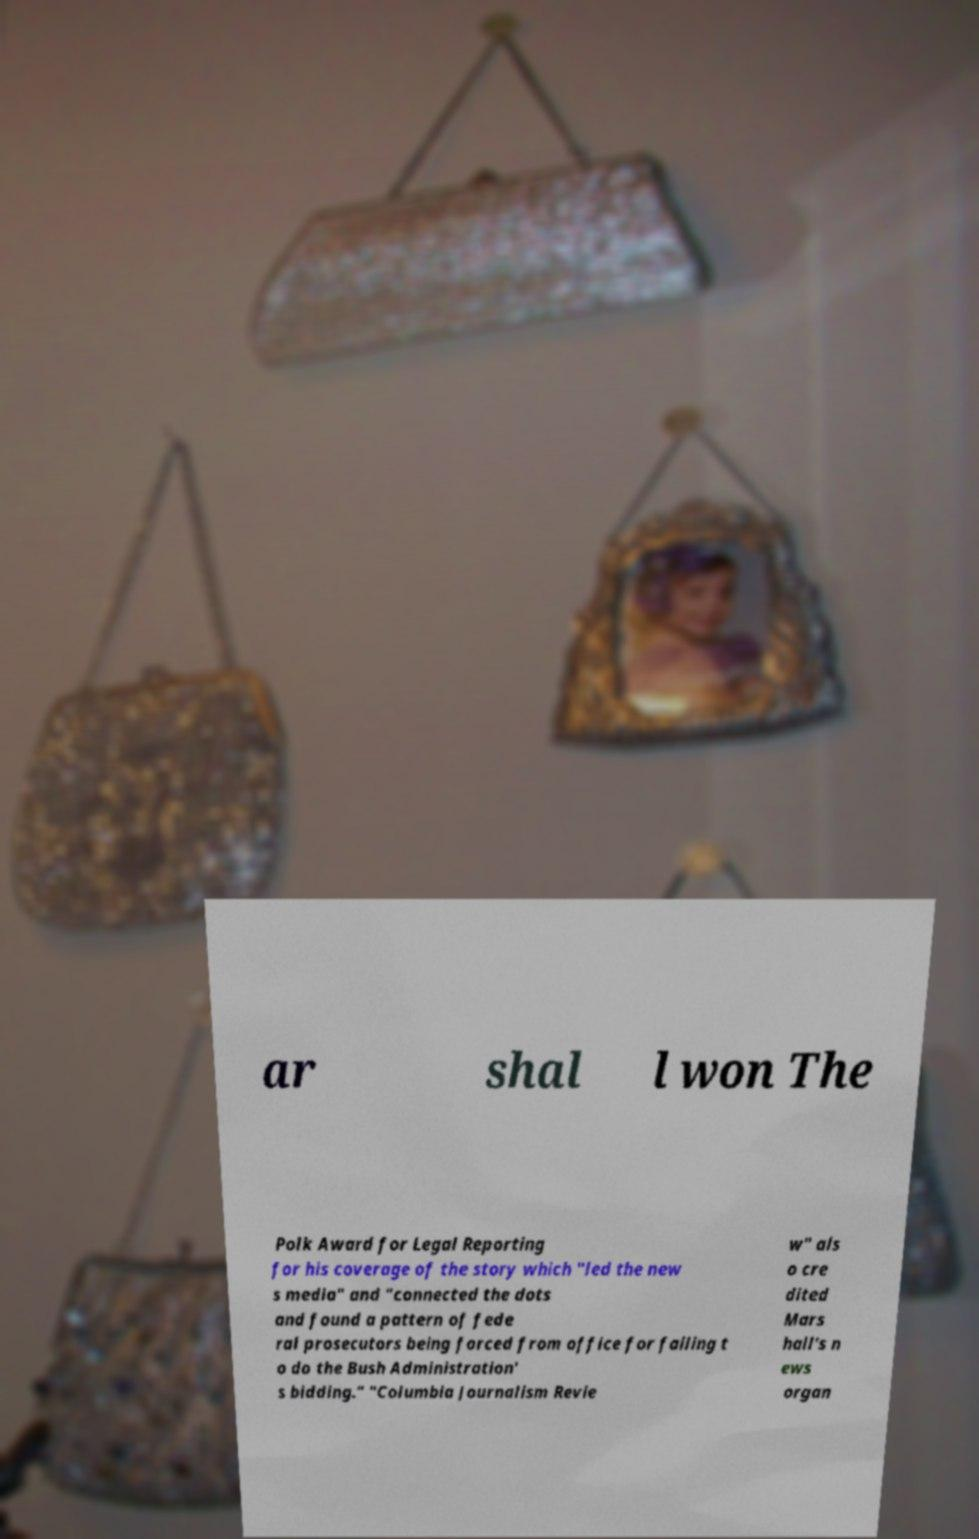What messages or text are displayed in this image? I need them in a readable, typed format. ar shal l won The Polk Award for Legal Reporting for his coverage of the story which "led the new s media" and "connected the dots and found a pattern of fede ral prosecutors being forced from office for failing t o do the Bush Administration' s bidding." "Columbia Journalism Revie w" als o cre dited Mars hall's n ews organ 